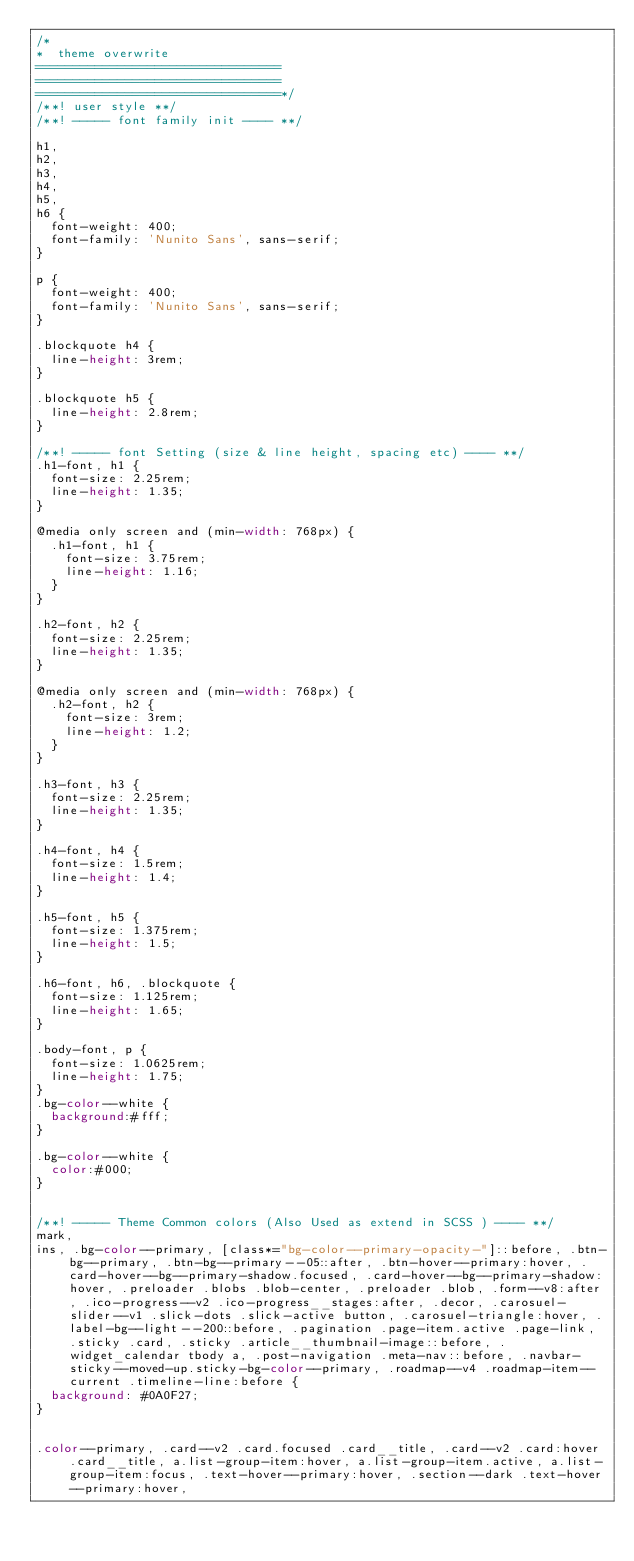<code> <loc_0><loc_0><loc_500><loc_500><_CSS_>/*
*  theme overwrite 
=================================
=================================
=================================*/
/**! user style **/
/**! ----- font family init ---- **/

h1,
h2,
h3,
h4,
h5,
h6 {
  font-weight: 400;
  font-family: 'Nunito Sans', sans-serif;
}

p {
  font-weight: 400;
  font-family: 'Nunito Sans', sans-serif;
}

.blockquote h4 {
  line-height: 3rem;
}

.blockquote h5 {
  line-height: 2.8rem;
}

/**! ----- font Setting (size & line height, spacing etc) ---- **/
.h1-font, h1 {
  font-size: 2.25rem;
  line-height: 1.35;
}

@media only screen and (min-width: 768px) {
  .h1-font, h1 {
    font-size: 3.75rem;
    line-height: 1.16;
  }
}

.h2-font, h2 {
  font-size: 2.25rem;
  line-height: 1.35;
}

@media only screen and (min-width: 768px) {
  .h2-font, h2 {
    font-size: 3rem;
    line-height: 1.2;
  }
}

.h3-font, h3 {
  font-size: 2.25rem;
  line-height: 1.35;
}

.h4-font, h4 {
  font-size: 1.5rem;
  line-height: 1.4;
}

.h5-font, h5 {
  font-size: 1.375rem;
  line-height: 1.5;
}

.h6-font, h6, .blockquote {
  font-size: 1.125rem;
  line-height: 1.65;
}

.body-font, p {
  font-size: 1.0625rem;
  line-height: 1.75;
}
.bg-color--white {
  background:#fff;
}

.bg-color--white {
  color:#000;
}


/**! ----- Theme Common colors (Also Used as extend in SCSS ) ---- **/
mark,
ins, .bg-color--primary, [class*="bg-color--primary-opacity-"]::before, .btn-bg--primary, .btn-bg--primary--05::after, .btn-hover--primary:hover, .card-hover--bg--primary-shadow.focused, .card-hover--bg--primary-shadow:hover, .preloader .blobs .blob-center, .preloader .blob, .form--v8:after, .ico-progress--v2 .ico-progress__stages:after, .decor, .carosuel-slider--v1 .slick-dots .slick-active button, .carosuel-triangle:hover, .label-bg--light--200::before, .pagination .page-item.active .page-link, .sticky .card, .sticky .article__thumbnail-image::before, .widget_calendar tbody a, .post-navigation .meta-nav::before, .navbar-sticky--moved-up.sticky-bg-color--primary, .roadmap--v4 .roadmap-item--current .timeline-line:before {
  background: #0A0F27;
}


.color--primary, .card--v2 .card.focused .card__title, .card--v2 .card:hover .card__title, a.list-group-item:hover, a.list-group-item.active, a.list-group-item:focus, .text-hover--primary:hover, .section--dark .text-hover--primary:hover,</code> 